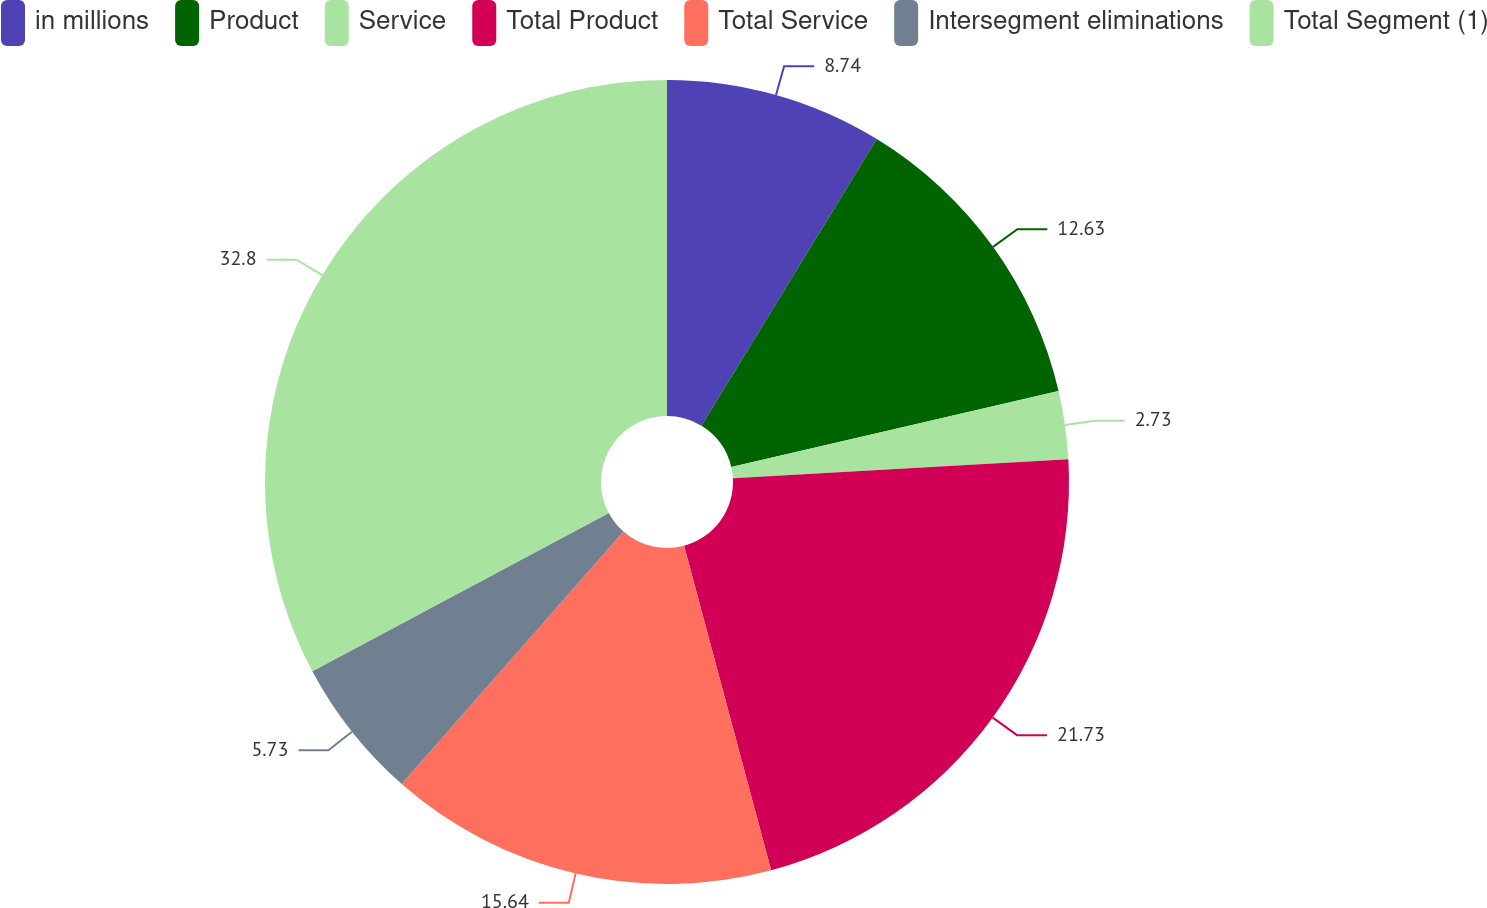Convert chart to OTSL. <chart><loc_0><loc_0><loc_500><loc_500><pie_chart><fcel>in millions<fcel>Product<fcel>Service<fcel>Total Product<fcel>Total Service<fcel>Intersegment eliminations<fcel>Total Segment (1)<nl><fcel>8.74%<fcel>12.63%<fcel>2.73%<fcel>21.73%<fcel>15.64%<fcel>5.73%<fcel>32.8%<nl></chart> 